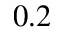Convert formula to latex. <formula><loc_0><loc_0><loc_500><loc_500>0 . 2</formula> 